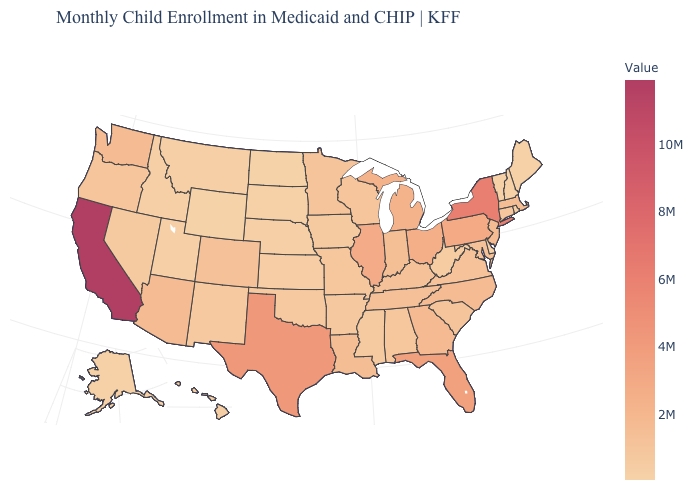Does the map have missing data?
Answer briefly. No. Which states have the highest value in the USA?
Give a very brief answer. California. Among the states that border Utah , does Idaho have the highest value?
Be succinct. No. Among the states that border Texas , which have the lowest value?
Write a very short answer. New Mexico. Is the legend a continuous bar?
Answer briefly. Yes. 